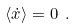Convert formula to latex. <formula><loc_0><loc_0><loc_500><loc_500>\langle \dot { x } \rangle = 0 \ .</formula> 